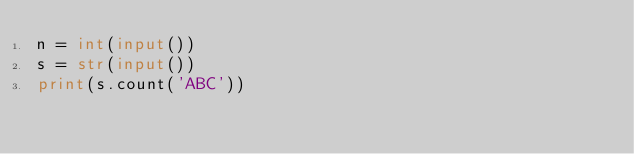<code> <loc_0><loc_0><loc_500><loc_500><_Python_>n = int(input())
s = str(input())
print(s.count('ABC'))</code> 